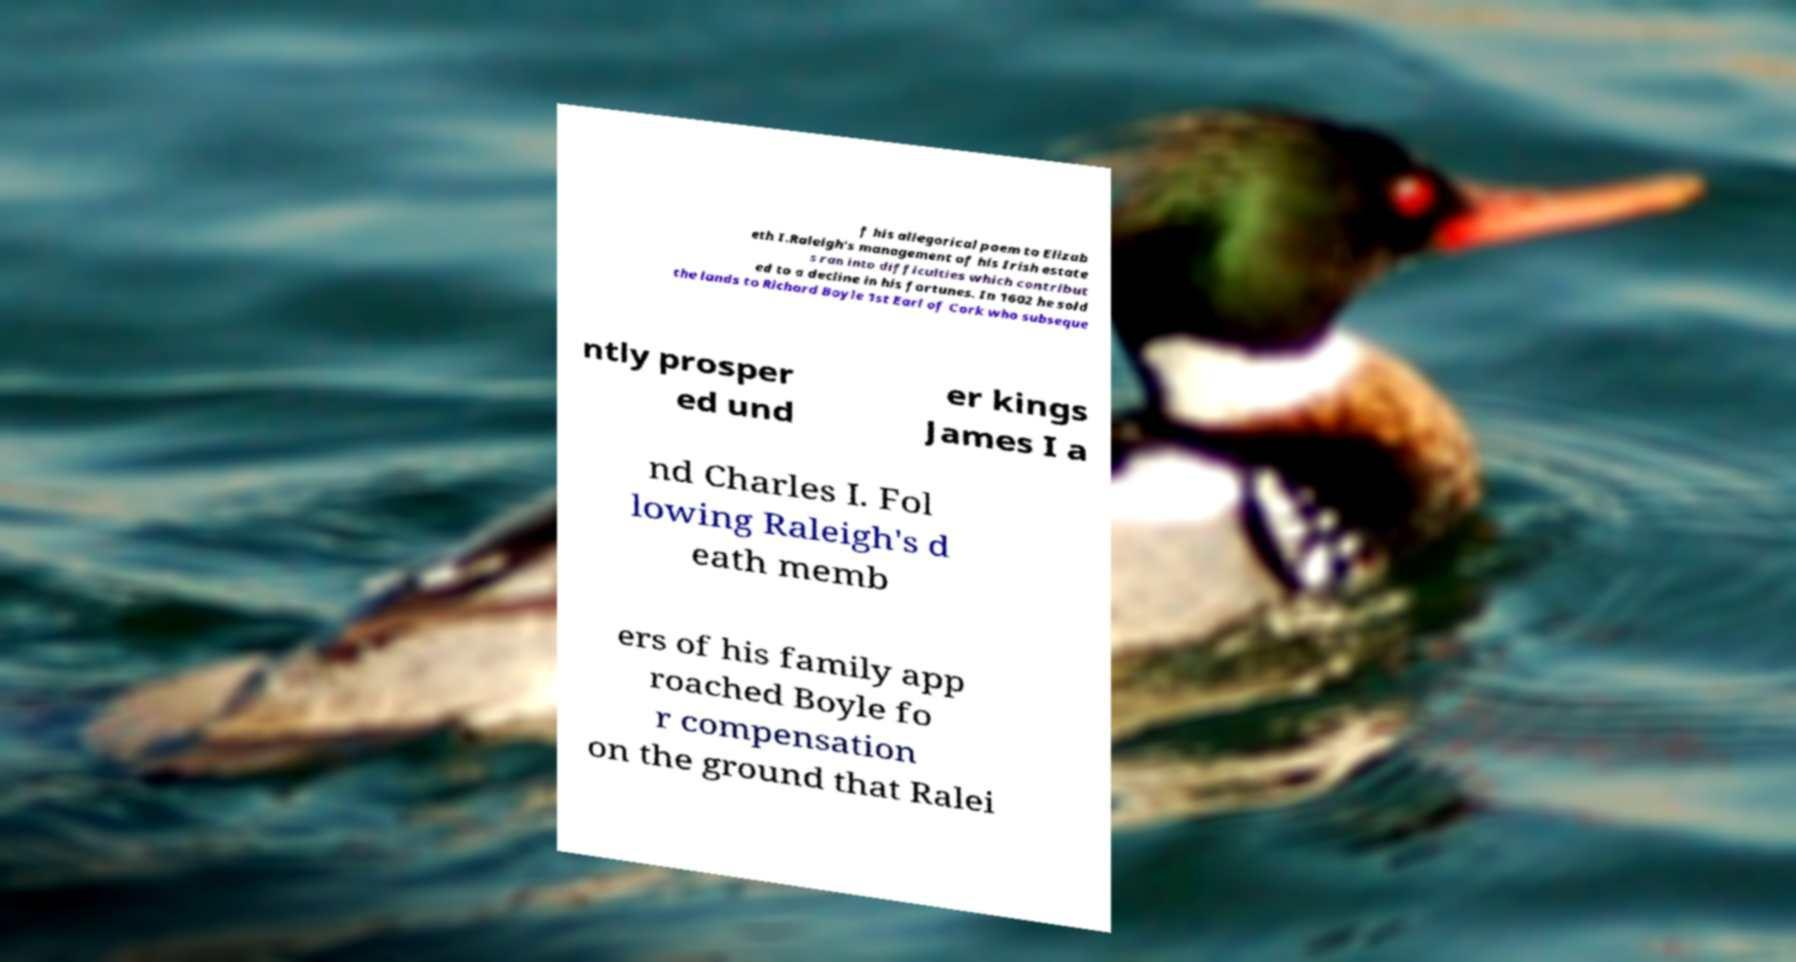Could you assist in decoding the text presented in this image and type it out clearly? f his allegorical poem to Elizab eth I.Raleigh's management of his Irish estate s ran into difficulties which contribut ed to a decline in his fortunes. In 1602 he sold the lands to Richard Boyle 1st Earl of Cork who subseque ntly prosper ed und er kings James I a nd Charles I. Fol lowing Raleigh's d eath memb ers of his family app roached Boyle fo r compensation on the ground that Ralei 